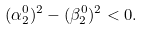Convert formula to latex. <formula><loc_0><loc_0><loc_500><loc_500>( \alpha ^ { 0 } _ { 2 } ) ^ { 2 } - ( \beta ^ { 0 } _ { 2 } ) ^ { 2 } < 0 .</formula> 